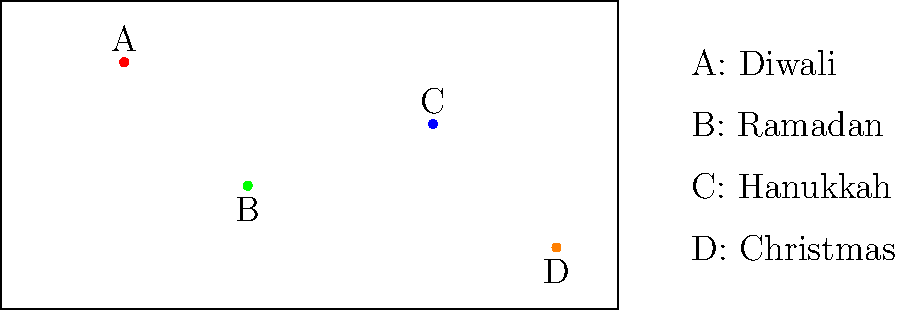Based on the global map showing religious festivals, which two celebrations are geographically closest to each other? To determine which two religious festivals are geographically closest, we need to analyze the positions of the event markers on the map:

1. Marker A (Diwali) is located in the upper-left quadrant of the map.
2. Marker B (Ramadan) is in the lower-left quadrant.
3. Marker C (Hanukkah) is in the upper-right quadrant.
4. Marker D (Christmas) is in the lower-right quadrant.

To find the closest pair, we need to visually compare the distances between each pair of points:

1. A-B: Moderate distance
2. A-C: Large distance
3. A-D: Very large distance
4. B-C: Moderate distance
5. B-D: Large distance
6. C-D: Small distance

By visual inspection, we can see that markers C (Hanukkah) and D (Christmas) are the closest to each other on the map.

This proximity reflects the historical and geographical connections between Judaism and Christianity, as both religions originated in the Middle East. Hanukkah is often celebrated in Israel and by Jewish communities worldwide, while Christmas is widely celebrated in many countries, with a significant presence in Europe and the Americas.
Answer: Hanukkah and Christmas 